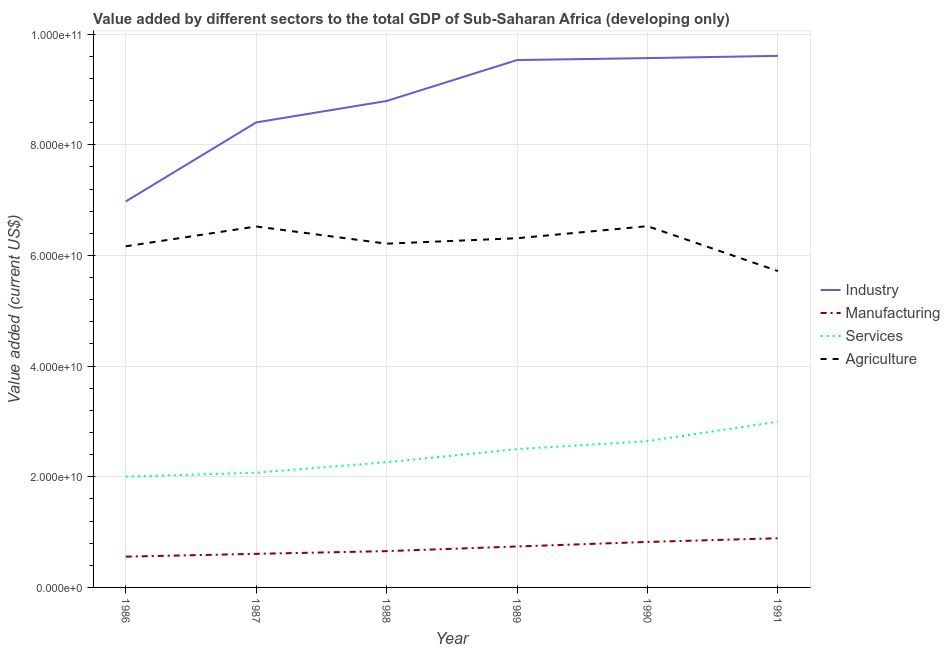Does the line corresponding to value added by manufacturing sector intersect with the line corresponding to value added by agricultural sector?
Ensure brevity in your answer.  No. Is the number of lines equal to the number of legend labels?
Provide a succinct answer. Yes. What is the value added by services sector in 1990?
Ensure brevity in your answer.  2.64e+1. Across all years, what is the maximum value added by agricultural sector?
Give a very brief answer. 6.53e+1. Across all years, what is the minimum value added by industrial sector?
Keep it short and to the point. 6.98e+1. What is the total value added by industrial sector in the graph?
Make the answer very short. 5.29e+11. What is the difference between the value added by agricultural sector in 1990 and that in 1991?
Provide a succinct answer. 8.11e+09. What is the difference between the value added by agricultural sector in 1988 and the value added by services sector in 1986?
Ensure brevity in your answer.  4.21e+1. What is the average value added by agricultural sector per year?
Your answer should be compact. 6.24e+1. In the year 1986, what is the difference between the value added by services sector and value added by agricultural sector?
Provide a succinct answer. -4.16e+1. In how many years, is the value added by industrial sector greater than 64000000000 US$?
Keep it short and to the point. 6. What is the ratio of the value added by industrial sector in 1987 to that in 1990?
Ensure brevity in your answer.  0.88. What is the difference between the highest and the second highest value added by manufacturing sector?
Offer a terse response. 6.66e+08. What is the difference between the highest and the lowest value added by manufacturing sector?
Keep it short and to the point. 3.33e+09. Is it the case that in every year, the sum of the value added by industrial sector and value added by manufacturing sector is greater than the value added by services sector?
Ensure brevity in your answer.  Yes. Is the value added by agricultural sector strictly greater than the value added by services sector over the years?
Give a very brief answer. Yes. How many lines are there?
Your answer should be very brief. 4. Does the graph contain any zero values?
Ensure brevity in your answer.  No. How many legend labels are there?
Offer a terse response. 4. How are the legend labels stacked?
Your answer should be very brief. Vertical. What is the title of the graph?
Your answer should be very brief. Value added by different sectors to the total GDP of Sub-Saharan Africa (developing only). What is the label or title of the X-axis?
Your answer should be very brief. Year. What is the label or title of the Y-axis?
Give a very brief answer. Value added (current US$). What is the Value added (current US$) in Industry in 1986?
Offer a terse response. 6.98e+1. What is the Value added (current US$) of Manufacturing in 1986?
Provide a short and direct response. 5.56e+09. What is the Value added (current US$) in Services in 1986?
Keep it short and to the point. 2.00e+1. What is the Value added (current US$) of Agriculture in 1986?
Provide a short and direct response. 6.17e+1. What is the Value added (current US$) of Industry in 1987?
Your response must be concise. 8.40e+1. What is the Value added (current US$) of Manufacturing in 1987?
Provide a short and direct response. 6.07e+09. What is the Value added (current US$) in Services in 1987?
Offer a terse response. 2.07e+1. What is the Value added (current US$) in Agriculture in 1987?
Keep it short and to the point. 6.52e+1. What is the Value added (current US$) of Industry in 1988?
Offer a very short reply. 8.79e+1. What is the Value added (current US$) of Manufacturing in 1988?
Make the answer very short. 6.56e+09. What is the Value added (current US$) in Services in 1988?
Give a very brief answer. 2.26e+1. What is the Value added (current US$) in Agriculture in 1988?
Your answer should be compact. 6.21e+1. What is the Value added (current US$) of Industry in 1989?
Your answer should be compact. 9.53e+1. What is the Value added (current US$) of Manufacturing in 1989?
Your response must be concise. 7.40e+09. What is the Value added (current US$) of Services in 1989?
Your answer should be compact. 2.50e+1. What is the Value added (current US$) of Agriculture in 1989?
Keep it short and to the point. 6.31e+1. What is the Value added (current US$) in Industry in 1990?
Your answer should be very brief. 9.57e+1. What is the Value added (current US$) in Manufacturing in 1990?
Provide a short and direct response. 8.22e+09. What is the Value added (current US$) of Services in 1990?
Provide a short and direct response. 2.64e+1. What is the Value added (current US$) of Agriculture in 1990?
Make the answer very short. 6.53e+1. What is the Value added (current US$) of Industry in 1991?
Ensure brevity in your answer.  9.61e+1. What is the Value added (current US$) in Manufacturing in 1991?
Provide a short and direct response. 8.89e+09. What is the Value added (current US$) in Services in 1991?
Offer a terse response. 3.00e+1. What is the Value added (current US$) in Agriculture in 1991?
Keep it short and to the point. 5.72e+1. Across all years, what is the maximum Value added (current US$) of Industry?
Provide a short and direct response. 9.61e+1. Across all years, what is the maximum Value added (current US$) in Manufacturing?
Make the answer very short. 8.89e+09. Across all years, what is the maximum Value added (current US$) in Services?
Ensure brevity in your answer.  3.00e+1. Across all years, what is the maximum Value added (current US$) of Agriculture?
Your answer should be very brief. 6.53e+1. Across all years, what is the minimum Value added (current US$) in Industry?
Provide a short and direct response. 6.98e+1. Across all years, what is the minimum Value added (current US$) of Manufacturing?
Provide a succinct answer. 5.56e+09. Across all years, what is the minimum Value added (current US$) of Services?
Make the answer very short. 2.00e+1. Across all years, what is the minimum Value added (current US$) in Agriculture?
Your answer should be compact. 5.72e+1. What is the total Value added (current US$) in Industry in the graph?
Keep it short and to the point. 5.29e+11. What is the total Value added (current US$) in Manufacturing in the graph?
Ensure brevity in your answer.  4.27e+1. What is the total Value added (current US$) of Services in the graph?
Make the answer very short. 1.45e+11. What is the total Value added (current US$) in Agriculture in the graph?
Ensure brevity in your answer.  3.75e+11. What is the difference between the Value added (current US$) of Industry in 1986 and that in 1987?
Offer a terse response. -1.43e+1. What is the difference between the Value added (current US$) of Manufacturing in 1986 and that in 1987?
Make the answer very short. -5.08e+08. What is the difference between the Value added (current US$) of Services in 1986 and that in 1987?
Ensure brevity in your answer.  -7.20e+08. What is the difference between the Value added (current US$) of Agriculture in 1986 and that in 1987?
Ensure brevity in your answer.  -3.58e+09. What is the difference between the Value added (current US$) of Industry in 1986 and that in 1988?
Provide a short and direct response. -1.82e+1. What is the difference between the Value added (current US$) of Manufacturing in 1986 and that in 1988?
Provide a succinct answer. -9.98e+08. What is the difference between the Value added (current US$) in Services in 1986 and that in 1988?
Offer a very short reply. -2.62e+09. What is the difference between the Value added (current US$) of Agriculture in 1986 and that in 1988?
Ensure brevity in your answer.  -4.79e+08. What is the difference between the Value added (current US$) in Industry in 1986 and that in 1989?
Keep it short and to the point. -2.56e+1. What is the difference between the Value added (current US$) of Manufacturing in 1986 and that in 1989?
Offer a terse response. -1.84e+09. What is the difference between the Value added (current US$) of Services in 1986 and that in 1989?
Provide a succinct answer. -4.98e+09. What is the difference between the Value added (current US$) in Agriculture in 1986 and that in 1989?
Your response must be concise. -1.46e+09. What is the difference between the Value added (current US$) of Industry in 1986 and that in 1990?
Your response must be concise. -2.59e+1. What is the difference between the Value added (current US$) of Manufacturing in 1986 and that in 1990?
Offer a very short reply. -2.66e+09. What is the difference between the Value added (current US$) in Services in 1986 and that in 1990?
Make the answer very short. -6.43e+09. What is the difference between the Value added (current US$) in Agriculture in 1986 and that in 1990?
Make the answer very short. -3.64e+09. What is the difference between the Value added (current US$) in Industry in 1986 and that in 1991?
Give a very brief answer. -2.63e+1. What is the difference between the Value added (current US$) of Manufacturing in 1986 and that in 1991?
Make the answer very short. -3.33e+09. What is the difference between the Value added (current US$) of Services in 1986 and that in 1991?
Provide a short and direct response. -9.94e+09. What is the difference between the Value added (current US$) of Agriculture in 1986 and that in 1991?
Your answer should be compact. 4.47e+09. What is the difference between the Value added (current US$) of Industry in 1987 and that in 1988?
Make the answer very short. -3.88e+09. What is the difference between the Value added (current US$) in Manufacturing in 1987 and that in 1988?
Offer a very short reply. -4.90e+08. What is the difference between the Value added (current US$) of Services in 1987 and that in 1988?
Offer a very short reply. -1.90e+09. What is the difference between the Value added (current US$) of Agriculture in 1987 and that in 1988?
Give a very brief answer. 3.11e+09. What is the difference between the Value added (current US$) in Industry in 1987 and that in 1989?
Provide a succinct answer. -1.13e+1. What is the difference between the Value added (current US$) of Manufacturing in 1987 and that in 1989?
Your answer should be very brief. -1.33e+09. What is the difference between the Value added (current US$) of Services in 1987 and that in 1989?
Your answer should be very brief. -4.26e+09. What is the difference between the Value added (current US$) of Agriculture in 1987 and that in 1989?
Give a very brief answer. 2.12e+09. What is the difference between the Value added (current US$) in Industry in 1987 and that in 1990?
Your answer should be compact. -1.16e+1. What is the difference between the Value added (current US$) of Manufacturing in 1987 and that in 1990?
Ensure brevity in your answer.  -2.15e+09. What is the difference between the Value added (current US$) of Services in 1987 and that in 1990?
Offer a very short reply. -5.71e+09. What is the difference between the Value added (current US$) in Agriculture in 1987 and that in 1990?
Offer a very short reply. -5.30e+07. What is the difference between the Value added (current US$) of Industry in 1987 and that in 1991?
Provide a short and direct response. -1.20e+1. What is the difference between the Value added (current US$) in Manufacturing in 1987 and that in 1991?
Keep it short and to the point. -2.82e+09. What is the difference between the Value added (current US$) in Services in 1987 and that in 1991?
Ensure brevity in your answer.  -9.22e+09. What is the difference between the Value added (current US$) of Agriculture in 1987 and that in 1991?
Offer a very short reply. 8.06e+09. What is the difference between the Value added (current US$) of Industry in 1988 and that in 1989?
Provide a succinct answer. -7.40e+09. What is the difference between the Value added (current US$) of Manufacturing in 1988 and that in 1989?
Provide a succinct answer. -8.40e+08. What is the difference between the Value added (current US$) of Services in 1988 and that in 1989?
Your response must be concise. -2.37e+09. What is the difference between the Value added (current US$) in Agriculture in 1988 and that in 1989?
Your response must be concise. -9.84e+08. What is the difference between the Value added (current US$) of Industry in 1988 and that in 1990?
Give a very brief answer. -7.75e+09. What is the difference between the Value added (current US$) in Manufacturing in 1988 and that in 1990?
Your answer should be very brief. -1.66e+09. What is the difference between the Value added (current US$) in Services in 1988 and that in 1990?
Your response must be concise. -3.81e+09. What is the difference between the Value added (current US$) in Agriculture in 1988 and that in 1990?
Your response must be concise. -3.16e+09. What is the difference between the Value added (current US$) in Industry in 1988 and that in 1991?
Provide a succinct answer. -8.15e+09. What is the difference between the Value added (current US$) in Manufacturing in 1988 and that in 1991?
Offer a terse response. -2.33e+09. What is the difference between the Value added (current US$) of Services in 1988 and that in 1991?
Your response must be concise. -7.32e+09. What is the difference between the Value added (current US$) in Agriculture in 1988 and that in 1991?
Provide a short and direct response. 4.95e+09. What is the difference between the Value added (current US$) in Industry in 1989 and that in 1990?
Provide a succinct answer. -3.49e+08. What is the difference between the Value added (current US$) in Manufacturing in 1989 and that in 1990?
Ensure brevity in your answer.  -8.22e+08. What is the difference between the Value added (current US$) of Services in 1989 and that in 1990?
Your response must be concise. -1.44e+09. What is the difference between the Value added (current US$) of Agriculture in 1989 and that in 1990?
Keep it short and to the point. -2.18e+09. What is the difference between the Value added (current US$) of Industry in 1989 and that in 1991?
Your answer should be compact. -7.55e+08. What is the difference between the Value added (current US$) in Manufacturing in 1989 and that in 1991?
Provide a short and direct response. -1.49e+09. What is the difference between the Value added (current US$) in Services in 1989 and that in 1991?
Provide a succinct answer. -4.95e+09. What is the difference between the Value added (current US$) in Agriculture in 1989 and that in 1991?
Your answer should be very brief. 5.93e+09. What is the difference between the Value added (current US$) of Industry in 1990 and that in 1991?
Provide a succinct answer. -4.06e+08. What is the difference between the Value added (current US$) in Manufacturing in 1990 and that in 1991?
Your answer should be very brief. -6.66e+08. What is the difference between the Value added (current US$) of Services in 1990 and that in 1991?
Your answer should be very brief. -3.51e+09. What is the difference between the Value added (current US$) in Agriculture in 1990 and that in 1991?
Keep it short and to the point. 8.11e+09. What is the difference between the Value added (current US$) in Industry in 1986 and the Value added (current US$) in Manufacturing in 1987?
Keep it short and to the point. 6.37e+1. What is the difference between the Value added (current US$) of Industry in 1986 and the Value added (current US$) of Services in 1987?
Keep it short and to the point. 4.90e+1. What is the difference between the Value added (current US$) in Industry in 1986 and the Value added (current US$) in Agriculture in 1987?
Provide a succinct answer. 4.53e+09. What is the difference between the Value added (current US$) in Manufacturing in 1986 and the Value added (current US$) in Services in 1987?
Offer a terse response. -1.52e+1. What is the difference between the Value added (current US$) of Manufacturing in 1986 and the Value added (current US$) of Agriculture in 1987?
Offer a very short reply. -5.97e+1. What is the difference between the Value added (current US$) in Services in 1986 and the Value added (current US$) in Agriculture in 1987?
Give a very brief answer. -4.52e+1. What is the difference between the Value added (current US$) in Industry in 1986 and the Value added (current US$) in Manufacturing in 1988?
Your answer should be compact. 6.32e+1. What is the difference between the Value added (current US$) in Industry in 1986 and the Value added (current US$) in Services in 1988?
Your answer should be compact. 4.71e+1. What is the difference between the Value added (current US$) in Industry in 1986 and the Value added (current US$) in Agriculture in 1988?
Your answer should be very brief. 7.63e+09. What is the difference between the Value added (current US$) in Manufacturing in 1986 and the Value added (current US$) in Services in 1988?
Provide a succinct answer. -1.71e+1. What is the difference between the Value added (current US$) in Manufacturing in 1986 and the Value added (current US$) in Agriculture in 1988?
Offer a very short reply. -5.66e+1. What is the difference between the Value added (current US$) of Services in 1986 and the Value added (current US$) of Agriculture in 1988?
Give a very brief answer. -4.21e+1. What is the difference between the Value added (current US$) in Industry in 1986 and the Value added (current US$) in Manufacturing in 1989?
Give a very brief answer. 6.24e+1. What is the difference between the Value added (current US$) of Industry in 1986 and the Value added (current US$) of Services in 1989?
Provide a succinct answer. 4.48e+1. What is the difference between the Value added (current US$) of Industry in 1986 and the Value added (current US$) of Agriculture in 1989?
Your answer should be very brief. 6.65e+09. What is the difference between the Value added (current US$) in Manufacturing in 1986 and the Value added (current US$) in Services in 1989?
Offer a very short reply. -1.94e+1. What is the difference between the Value added (current US$) of Manufacturing in 1986 and the Value added (current US$) of Agriculture in 1989?
Ensure brevity in your answer.  -5.76e+1. What is the difference between the Value added (current US$) in Services in 1986 and the Value added (current US$) in Agriculture in 1989?
Make the answer very short. -4.31e+1. What is the difference between the Value added (current US$) in Industry in 1986 and the Value added (current US$) in Manufacturing in 1990?
Offer a very short reply. 6.15e+1. What is the difference between the Value added (current US$) in Industry in 1986 and the Value added (current US$) in Services in 1990?
Make the answer very short. 4.33e+1. What is the difference between the Value added (current US$) of Industry in 1986 and the Value added (current US$) of Agriculture in 1990?
Make the answer very short. 4.47e+09. What is the difference between the Value added (current US$) in Manufacturing in 1986 and the Value added (current US$) in Services in 1990?
Your answer should be compact. -2.09e+1. What is the difference between the Value added (current US$) of Manufacturing in 1986 and the Value added (current US$) of Agriculture in 1990?
Give a very brief answer. -5.97e+1. What is the difference between the Value added (current US$) of Services in 1986 and the Value added (current US$) of Agriculture in 1990?
Ensure brevity in your answer.  -4.53e+1. What is the difference between the Value added (current US$) in Industry in 1986 and the Value added (current US$) in Manufacturing in 1991?
Offer a terse response. 6.09e+1. What is the difference between the Value added (current US$) of Industry in 1986 and the Value added (current US$) of Services in 1991?
Your answer should be compact. 3.98e+1. What is the difference between the Value added (current US$) in Industry in 1986 and the Value added (current US$) in Agriculture in 1991?
Give a very brief answer. 1.26e+1. What is the difference between the Value added (current US$) of Manufacturing in 1986 and the Value added (current US$) of Services in 1991?
Your answer should be very brief. -2.44e+1. What is the difference between the Value added (current US$) in Manufacturing in 1986 and the Value added (current US$) in Agriculture in 1991?
Provide a succinct answer. -5.16e+1. What is the difference between the Value added (current US$) of Services in 1986 and the Value added (current US$) of Agriculture in 1991?
Keep it short and to the point. -3.72e+1. What is the difference between the Value added (current US$) in Industry in 1987 and the Value added (current US$) in Manufacturing in 1988?
Offer a terse response. 7.75e+1. What is the difference between the Value added (current US$) of Industry in 1987 and the Value added (current US$) of Services in 1988?
Provide a short and direct response. 6.14e+1. What is the difference between the Value added (current US$) in Industry in 1987 and the Value added (current US$) in Agriculture in 1988?
Provide a short and direct response. 2.19e+1. What is the difference between the Value added (current US$) of Manufacturing in 1987 and the Value added (current US$) of Services in 1988?
Offer a terse response. -1.66e+1. What is the difference between the Value added (current US$) of Manufacturing in 1987 and the Value added (current US$) of Agriculture in 1988?
Ensure brevity in your answer.  -5.61e+1. What is the difference between the Value added (current US$) of Services in 1987 and the Value added (current US$) of Agriculture in 1988?
Give a very brief answer. -4.14e+1. What is the difference between the Value added (current US$) of Industry in 1987 and the Value added (current US$) of Manufacturing in 1989?
Provide a succinct answer. 7.66e+1. What is the difference between the Value added (current US$) of Industry in 1987 and the Value added (current US$) of Services in 1989?
Keep it short and to the point. 5.91e+1. What is the difference between the Value added (current US$) in Industry in 1987 and the Value added (current US$) in Agriculture in 1989?
Your response must be concise. 2.09e+1. What is the difference between the Value added (current US$) of Manufacturing in 1987 and the Value added (current US$) of Services in 1989?
Provide a short and direct response. -1.89e+1. What is the difference between the Value added (current US$) of Manufacturing in 1987 and the Value added (current US$) of Agriculture in 1989?
Keep it short and to the point. -5.70e+1. What is the difference between the Value added (current US$) of Services in 1987 and the Value added (current US$) of Agriculture in 1989?
Offer a terse response. -4.24e+1. What is the difference between the Value added (current US$) of Industry in 1987 and the Value added (current US$) of Manufacturing in 1990?
Ensure brevity in your answer.  7.58e+1. What is the difference between the Value added (current US$) in Industry in 1987 and the Value added (current US$) in Services in 1990?
Offer a very short reply. 5.76e+1. What is the difference between the Value added (current US$) in Industry in 1987 and the Value added (current US$) in Agriculture in 1990?
Provide a succinct answer. 1.88e+1. What is the difference between the Value added (current US$) of Manufacturing in 1987 and the Value added (current US$) of Services in 1990?
Offer a very short reply. -2.04e+1. What is the difference between the Value added (current US$) of Manufacturing in 1987 and the Value added (current US$) of Agriculture in 1990?
Your answer should be compact. -5.92e+1. What is the difference between the Value added (current US$) in Services in 1987 and the Value added (current US$) in Agriculture in 1990?
Offer a very short reply. -4.46e+1. What is the difference between the Value added (current US$) in Industry in 1987 and the Value added (current US$) in Manufacturing in 1991?
Offer a very short reply. 7.52e+1. What is the difference between the Value added (current US$) of Industry in 1987 and the Value added (current US$) of Services in 1991?
Your answer should be compact. 5.41e+1. What is the difference between the Value added (current US$) in Industry in 1987 and the Value added (current US$) in Agriculture in 1991?
Give a very brief answer. 2.69e+1. What is the difference between the Value added (current US$) of Manufacturing in 1987 and the Value added (current US$) of Services in 1991?
Your answer should be compact. -2.39e+1. What is the difference between the Value added (current US$) of Manufacturing in 1987 and the Value added (current US$) of Agriculture in 1991?
Provide a short and direct response. -5.11e+1. What is the difference between the Value added (current US$) of Services in 1987 and the Value added (current US$) of Agriculture in 1991?
Your response must be concise. -3.64e+1. What is the difference between the Value added (current US$) in Industry in 1988 and the Value added (current US$) in Manufacturing in 1989?
Provide a succinct answer. 8.05e+1. What is the difference between the Value added (current US$) in Industry in 1988 and the Value added (current US$) in Services in 1989?
Your answer should be compact. 6.29e+1. What is the difference between the Value added (current US$) of Industry in 1988 and the Value added (current US$) of Agriculture in 1989?
Keep it short and to the point. 2.48e+1. What is the difference between the Value added (current US$) in Manufacturing in 1988 and the Value added (current US$) in Services in 1989?
Your response must be concise. -1.84e+1. What is the difference between the Value added (current US$) in Manufacturing in 1988 and the Value added (current US$) in Agriculture in 1989?
Provide a succinct answer. -5.66e+1. What is the difference between the Value added (current US$) of Services in 1988 and the Value added (current US$) of Agriculture in 1989?
Offer a very short reply. -4.05e+1. What is the difference between the Value added (current US$) of Industry in 1988 and the Value added (current US$) of Manufacturing in 1990?
Keep it short and to the point. 7.97e+1. What is the difference between the Value added (current US$) of Industry in 1988 and the Value added (current US$) of Services in 1990?
Offer a terse response. 6.15e+1. What is the difference between the Value added (current US$) of Industry in 1988 and the Value added (current US$) of Agriculture in 1990?
Offer a terse response. 2.26e+1. What is the difference between the Value added (current US$) of Manufacturing in 1988 and the Value added (current US$) of Services in 1990?
Ensure brevity in your answer.  -1.99e+1. What is the difference between the Value added (current US$) in Manufacturing in 1988 and the Value added (current US$) in Agriculture in 1990?
Your response must be concise. -5.87e+1. What is the difference between the Value added (current US$) of Services in 1988 and the Value added (current US$) of Agriculture in 1990?
Offer a terse response. -4.27e+1. What is the difference between the Value added (current US$) of Industry in 1988 and the Value added (current US$) of Manufacturing in 1991?
Your answer should be very brief. 7.90e+1. What is the difference between the Value added (current US$) of Industry in 1988 and the Value added (current US$) of Services in 1991?
Your answer should be compact. 5.80e+1. What is the difference between the Value added (current US$) of Industry in 1988 and the Value added (current US$) of Agriculture in 1991?
Your answer should be compact. 3.07e+1. What is the difference between the Value added (current US$) of Manufacturing in 1988 and the Value added (current US$) of Services in 1991?
Provide a short and direct response. -2.34e+1. What is the difference between the Value added (current US$) in Manufacturing in 1988 and the Value added (current US$) in Agriculture in 1991?
Your answer should be compact. -5.06e+1. What is the difference between the Value added (current US$) in Services in 1988 and the Value added (current US$) in Agriculture in 1991?
Offer a very short reply. -3.46e+1. What is the difference between the Value added (current US$) of Industry in 1989 and the Value added (current US$) of Manufacturing in 1990?
Your answer should be very brief. 8.71e+1. What is the difference between the Value added (current US$) in Industry in 1989 and the Value added (current US$) in Services in 1990?
Your response must be concise. 6.89e+1. What is the difference between the Value added (current US$) of Industry in 1989 and the Value added (current US$) of Agriculture in 1990?
Offer a very short reply. 3.00e+1. What is the difference between the Value added (current US$) of Manufacturing in 1989 and the Value added (current US$) of Services in 1990?
Provide a short and direct response. -1.90e+1. What is the difference between the Value added (current US$) of Manufacturing in 1989 and the Value added (current US$) of Agriculture in 1990?
Your answer should be compact. -5.79e+1. What is the difference between the Value added (current US$) in Services in 1989 and the Value added (current US$) in Agriculture in 1990?
Your answer should be compact. -4.03e+1. What is the difference between the Value added (current US$) in Industry in 1989 and the Value added (current US$) in Manufacturing in 1991?
Provide a short and direct response. 8.64e+1. What is the difference between the Value added (current US$) in Industry in 1989 and the Value added (current US$) in Services in 1991?
Your answer should be compact. 6.54e+1. What is the difference between the Value added (current US$) of Industry in 1989 and the Value added (current US$) of Agriculture in 1991?
Ensure brevity in your answer.  3.81e+1. What is the difference between the Value added (current US$) in Manufacturing in 1989 and the Value added (current US$) in Services in 1991?
Make the answer very short. -2.26e+1. What is the difference between the Value added (current US$) in Manufacturing in 1989 and the Value added (current US$) in Agriculture in 1991?
Offer a very short reply. -4.98e+1. What is the difference between the Value added (current US$) in Services in 1989 and the Value added (current US$) in Agriculture in 1991?
Your answer should be very brief. -3.22e+1. What is the difference between the Value added (current US$) of Industry in 1990 and the Value added (current US$) of Manufacturing in 1991?
Your response must be concise. 8.68e+1. What is the difference between the Value added (current US$) in Industry in 1990 and the Value added (current US$) in Services in 1991?
Your answer should be compact. 6.57e+1. What is the difference between the Value added (current US$) of Industry in 1990 and the Value added (current US$) of Agriculture in 1991?
Provide a succinct answer. 3.85e+1. What is the difference between the Value added (current US$) in Manufacturing in 1990 and the Value added (current US$) in Services in 1991?
Make the answer very short. -2.17e+1. What is the difference between the Value added (current US$) in Manufacturing in 1990 and the Value added (current US$) in Agriculture in 1991?
Your response must be concise. -4.90e+1. What is the difference between the Value added (current US$) of Services in 1990 and the Value added (current US$) of Agriculture in 1991?
Make the answer very short. -3.07e+1. What is the average Value added (current US$) of Industry per year?
Give a very brief answer. 8.81e+1. What is the average Value added (current US$) in Manufacturing per year?
Keep it short and to the point. 7.12e+09. What is the average Value added (current US$) in Services per year?
Offer a very short reply. 2.41e+1. What is the average Value added (current US$) in Agriculture per year?
Your answer should be very brief. 6.24e+1. In the year 1986, what is the difference between the Value added (current US$) in Industry and Value added (current US$) in Manufacturing?
Offer a very short reply. 6.42e+1. In the year 1986, what is the difference between the Value added (current US$) in Industry and Value added (current US$) in Services?
Offer a very short reply. 4.97e+1. In the year 1986, what is the difference between the Value added (current US$) in Industry and Value added (current US$) in Agriculture?
Ensure brevity in your answer.  8.11e+09. In the year 1986, what is the difference between the Value added (current US$) of Manufacturing and Value added (current US$) of Services?
Your answer should be very brief. -1.45e+1. In the year 1986, what is the difference between the Value added (current US$) in Manufacturing and Value added (current US$) in Agriculture?
Your answer should be very brief. -5.61e+1. In the year 1986, what is the difference between the Value added (current US$) in Services and Value added (current US$) in Agriculture?
Make the answer very short. -4.16e+1. In the year 1987, what is the difference between the Value added (current US$) of Industry and Value added (current US$) of Manufacturing?
Give a very brief answer. 7.80e+1. In the year 1987, what is the difference between the Value added (current US$) of Industry and Value added (current US$) of Services?
Make the answer very short. 6.33e+1. In the year 1987, what is the difference between the Value added (current US$) of Industry and Value added (current US$) of Agriculture?
Your response must be concise. 1.88e+1. In the year 1987, what is the difference between the Value added (current US$) of Manufacturing and Value added (current US$) of Services?
Provide a succinct answer. -1.47e+1. In the year 1987, what is the difference between the Value added (current US$) in Manufacturing and Value added (current US$) in Agriculture?
Your response must be concise. -5.92e+1. In the year 1987, what is the difference between the Value added (current US$) in Services and Value added (current US$) in Agriculture?
Offer a terse response. -4.45e+1. In the year 1988, what is the difference between the Value added (current US$) of Industry and Value added (current US$) of Manufacturing?
Offer a terse response. 8.14e+1. In the year 1988, what is the difference between the Value added (current US$) of Industry and Value added (current US$) of Services?
Your answer should be very brief. 6.53e+1. In the year 1988, what is the difference between the Value added (current US$) in Industry and Value added (current US$) in Agriculture?
Your answer should be compact. 2.58e+1. In the year 1988, what is the difference between the Value added (current US$) of Manufacturing and Value added (current US$) of Services?
Keep it short and to the point. -1.61e+1. In the year 1988, what is the difference between the Value added (current US$) of Manufacturing and Value added (current US$) of Agriculture?
Your answer should be compact. -5.56e+1. In the year 1988, what is the difference between the Value added (current US$) in Services and Value added (current US$) in Agriculture?
Your answer should be very brief. -3.95e+1. In the year 1989, what is the difference between the Value added (current US$) of Industry and Value added (current US$) of Manufacturing?
Provide a short and direct response. 8.79e+1. In the year 1989, what is the difference between the Value added (current US$) of Industry and Value added (current US$) of Services?
Make the answer very short. 7.03e+1. In the year 1989, what is the difference between the Value added (current US$) of Industry and Value added (current US$) of Agriculture?
Ensure brevity in your answer.  3.22e+1. In the year 1989, what is the difference between the Value added (current US$) of Manufacturing and Value added (current US$) of Services?
Offer a terse response. -1.76e+1. In the year 1989, what is the difference between the Value added (current US$) of Manufacturing and Value added (current US$) of Agriculture?
Your answer should be very brief. -5.57e+1. In the year 1989, what is the difference between the Value added (current US$) in Services and Value added (current US$) in Agriculture?
Ensure brevity in your answer.  -3.81e+1. In the year 1990, what is the difference between the Value added (current US$) in Industry and Value added (current US$) in Manufacturing?
Offer a terse response. 8.74e+1. In the year 1990, what is the difference between the Value added (current US$) in Industry and Value added (current US$) in Services?
Your response must be concise. 6.92e+1. In the year 1990, what is the difference between the Value added (current US$) of Industry and Value added (current US$) of Agriculture?
Your answer should be compact. 3.04e+1. In the year 1990, what is the difference between the Value added (current US$) in Manufacturing and Value added (current US$) in Services?
Ensure brevity in your answer.  -1.82e+1. In the year 1990, what is the difference between the Value added (current US$) in Manufacturing and Value added (current US$) in Agriculture?
Give a very brief answer. -5.71e+1. In the year 1990, what is the difference between the Value added (current US$) in Services and Value added (current US$) in Agriculture?
Your response must be concise. -3.89e+1. In the year 1991, what is the difference between the Value added (current US$) in Industry and Value added (current US$) in Manufacturing?
Offer a terse response. 8.72e+1. In the year 1991, what is the difference between the Value added (current US$) of Industry and Value added (current US$) of Services?
Give a very brief answer. 6.61e+1. In the year 1991, what is the difference between the Value added (current US$) of Industry and Value added (current US$) of Agriculture?
Offer a terse response. 3.89e+1. In the year 1991, what is the difference between the Value added (current US$) in Manufacturing and Value added (current US$) in Services?
Offer a terse response. -2.11e+1. In the year 1991, what is the difference between the Value added (current US$) of Manufacturing and Value added (current US$) of Agriculture?
Keep it short and to the point. -4.83e+1. In the year 1991, what is the difference between the Value added (current US$) in Services and Value added (current US$) in Agriculture?
Provide a short and direct response. -2.72e+1. What is the ratio of the Value added (current US$) of Industry in 1986 to that in 1987?
Provide a short and direct response. 0.83. What is the ratio of the Value added (current US$) in Manufacturing in 1986 to that in 1987?
Offer a terse response. 0.92. What is the ratio of the Value added (current US$) in Services in 1986 to that in 1987?
Offer a very short reply. 0.97. What is the ratio of the Value added (current US$) of Agriculture in 1986 to that in 1987?
Make the answer very short. 0.95. What is the ratio of the Value added (current US$) of Industry in 1986 to that in 1988?
Your answer should be compact. 0.79. What is the ratio of the Value added (current US$) of Manufacturing in 1986 to that in 1988?
Give a very brief answer. 0.85. What is the ratio of the Value added (current US$) of Services in 1986 to that in 1988?
Offer a very short reply. 0.88. What is the ratio of the Value added (current US$) in Industry in 1986 to that in 1989?
Offer a very short reply. 0.73. What is the ratio of the Value added (current US$) in Manufacturing in 1986 to that in 1989?
Keep it short and to the point. 0.75. What is the ratio of the Value added (current US$) of Services in 1986 to that in 1989?
Your answer should be compact. 0.8. What is the ratio of the Value added (current US$) of Agriculture in 1986 to that in 1989?
Your response must be concise. 0.98. What is the ratio of the Value added (current US$) of Industry in 1986 to that in 1990?
Give a very brief answer. 0.73. What is the ratio of the Value added (current US$) in Manufacturing in 1986 to that in 1990?
Provide a succinct answer. 0.68. What is the ratio of the Value added (current US$) of Services in 1986 to that in 1990?
Your response must be concise. 0.76. What is the ratio of the Value added (current US$) in Agriculture in 1986 to that in 1990?
Your answer should be very brief. 0.94. What is the ratio of the Value added (current US$) of Industry in 1986 to that in 1991?
Your response must be concise. 0.73. What is the ratio of the Value added (current US$) of Manufacturing in 1986 to that in 1991?
Your answer should be compact. 0.63. What is the ratio of the Value added (current US$) in Services in 1986 to that in 1991?
Your answer should be very brief. 0.67. What is the ratio of the Value added (current US$) in Agriculture in 1986 to that in 1991?
Your answer should be very brief. 1.08. What is the ratio of the Value added (current US$) of Industry in 1987 to that in 1988?
Provide a short and direct response. 0.96. What is the ratio of the Value added (current US$) of Manufacturing in 1987 to that in 1988?
Provide a succinct answer. 0.93. What is the ratio of the Value added (current US$) of Services in 1987 to that in 1988?
Your answer should be very brief. 0.92. What is the ratio of the Value added (current US$) in Industry in 1987 to that in 1989?
Keep it short and to the point. 0.88. What is the ratio of the Value added (current US$) in Manufacturing in 1987 to that in 1989?
Ensure brevity in your answer.  0.82. What is the ratio of the Value added (current US$) of Services in 1987 to that in 1989?
Keep it short and to the point. 0.83. What is the ratio of the Value added (current US$) in Agriculture in 1987 to that in 1989?
Provide a short and direct response. 1.03. What is the ratio of the Value added (current US$) in Industry in 1987 to that in 1990?
Ensure brevity in your answer.  0.88. What is the ratio of the Value added (current US$) in Manufacturing in 1987 to that in 1990?
Offer a very short reply. 0.74. What is the ratio of the Value added (current US$) of Services in 1987 to that in 1990?
Your response must be concise. 0.78. What is the ratio of the Value added (current US$) of Industry in 1987 to that in 1991?
Make the answer very short. 0.87. What is the ratio of the Value added (current US$) in Manufacturing in 1987 to that in 1991?
Give a very brief answer. 0.68. What is the ratio of the Value added (current US$) of Services in 1987 to that in 1991?
Give a very brief answer. 0.69. What is the ratio of the Value added (current US$) of Agriculture in 1987 to that in 1991?
Make the answer very short. 1.14. What is the ratio of the Value added (current US$) in Industry in 1988 to that in 1989?
Provide a short and direct response. 0.92. What is the ratio of the Value added (current US$) of Manufacturing in 1988 to that in 1989?
Offer a terse response. 0.89. What is the ratio of the Value added (current US$) in Services in 1988 to that in 1989?
Your answer should be compact. 0.91. What is the ratio of the Value added (current US$) in Agriculture in 1988 to that in 1989?
Offer a terse response. 0.98. What is the ratio of the Value added (current US$) of Industry in 1988 to that in 1990?
Provide a short and direct response. 0.92. What is the ratio of the Value added (current US$) in Manufacturing in 1988 to that in 1990?
Offer a terse response. 0.8. What is the ratio of the Value added (current US$) of Services in 1988 to that in 1990?
Provide a succinct answer. 0.86. What is the ratio of the Value added (current US$) in Agriculture in 1988 to that in 1990?
Offer a terse response. 0.95. What is the ratio of the Value added (current US$) in Industry in 1988 to that in 1991?
Offer a very short reply. 0.92. What is the ratio of the Value added (current US$) of Manufacturing in 1988 to that in 1991?
Make the answer very short. 0.74. What is the ratio of the Value added (current US$) in Services in 1988 to that in 1991?
Provide a short and direct response. 0.76. What is the ratio of the Value added (current US$) in Agriculture in 1988 to that in 1991?
Offer a terse response. 1.09. What is the ratio of the Value added (current US$) of Manufacturing in 1989 to that in 1990?
Provide a short and direct response. 0.9. What is the ratio of the Value added (current US$) of Services in 1989 to that in 1990?
Provide a succinct answer. 0.95. What is the ratio of the Value added (current US$) in Agriculture in 1989 to that in 1990?
Provide a succinct answer. 0.97. What is the ratio of the Value added (current US$) in Manufacturing in 1989 to that in 1991?
Make the answer very short. 0.83. What is the ratio of the Value added (current US$) of Services in 1989 to that in 1991?
Your answer should be compact. 0.83. What is the ratio of the Value added (current US$) of Agriculture in 1989 to that in 1991?
Your answer should be compact. 1.1. What is the ratio of the Value added (current US$) of Manufacturing in 1990 to that in 1991?
Provide a short and direct response. 0.93. What is the ratio of the Value added (current US$) in Services in 1990 to that in 1991?
Your response must be concise. 0.88. What is the ratio of the Value added (current US$) in Agriculture in 1990 to that in 1991?
Your response must be concise. 1.14. What is the difference between the highest and the second highest Value added (current US$) in Industry?
Provide a short and direct response. 4.06e+08. What is the difference between the highest and the second highest Value added (current US$) in Manufacturing?
Offer a very short reply. 6.66e+08. What is the difference between the highest and the second highest Value added (current US$) of Services?
Offer a terse response. 3.51e+09. What is the difference between the highest and the second highest Value added (current US$) in Agriculture?
Your answer should be compact. 5.30e+07. What is the difference between the highest and the lowest Value added (current US$) of Industry?
Your response must be concise. 2.63e+1. What is the difference between the highest and the lowest Value added (current US$) in Manufacturing?
Offer a terse response. 3.33e+09. What is the difference between the highest and the lowest Value added (current US$) of Services?
Your answer should be very brief. 9.94e+09. What is the difference between the highest and the lowest Value added (current US$) in Agriculture?
Your answer should be very brief. 8.11e+09. 